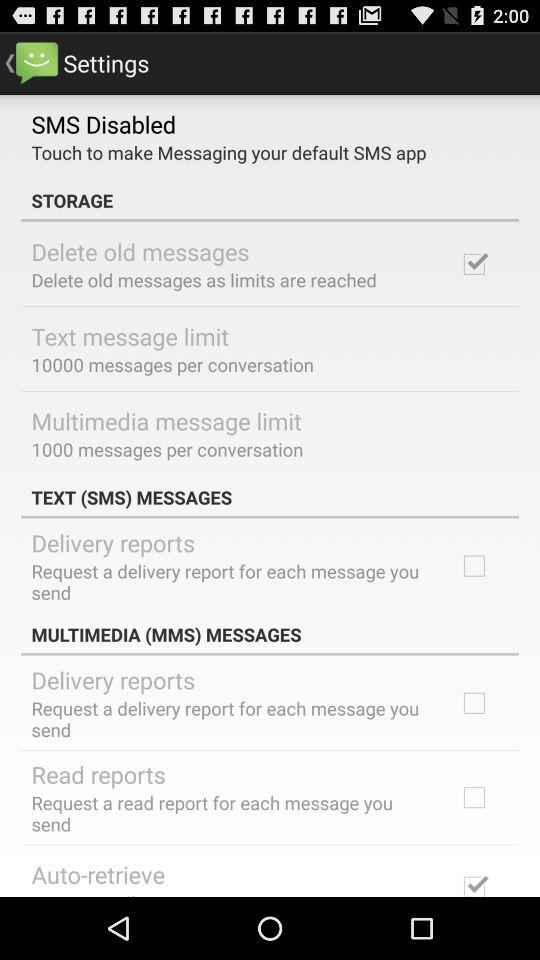Which settings are unchecked in "TEXT (SMS) MESSAGES"? The setting that are unchecked in "TEXT (SMS) MESSAGES" is "Delivery reports". 